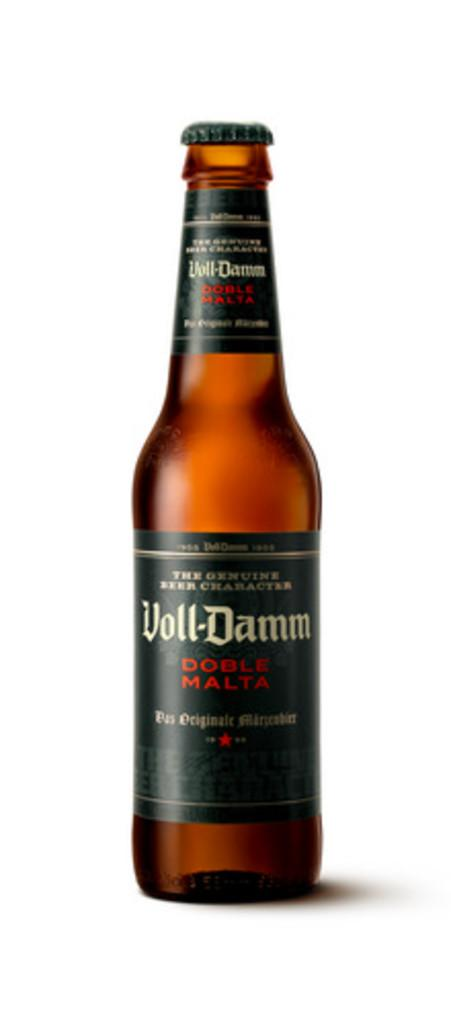<image>
Create a compact narrative representing the image presented. A bottle of Voll-Damm Doble Malta stands against a white background 